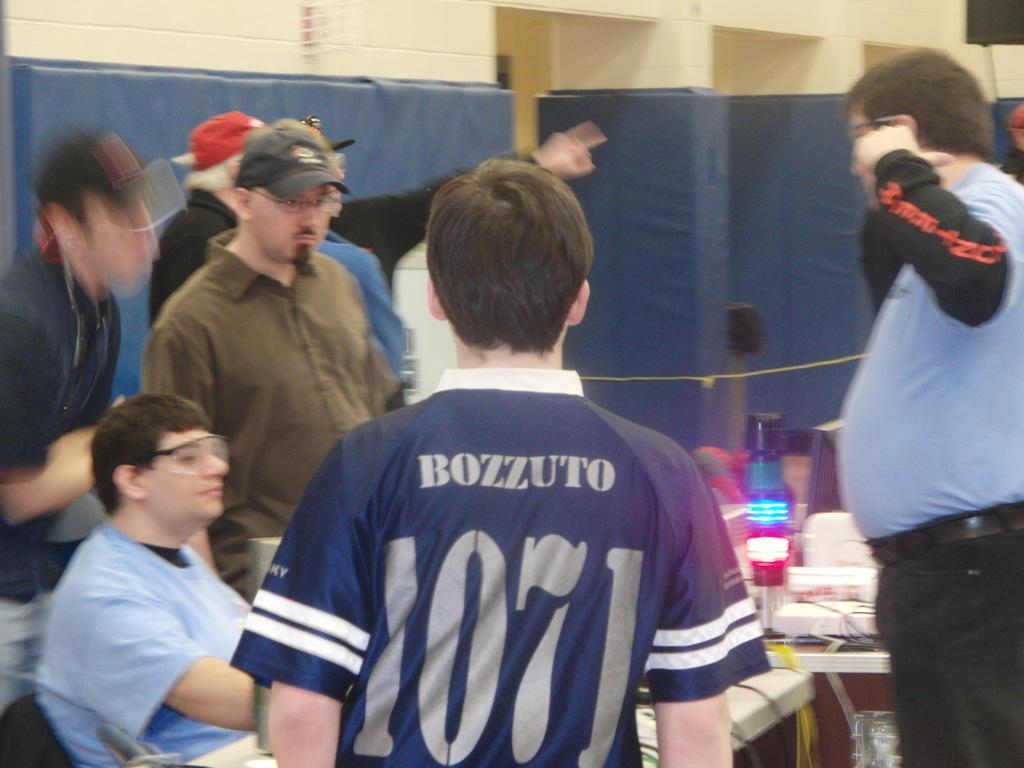<image>
Summarize the visual content of the image. A group of men are speaking at a table as someone wearing a jersey with the name Bozzuto stands between them. 